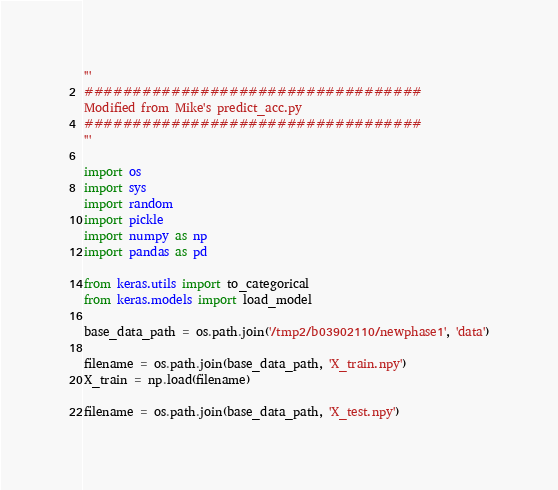Convert code to text. <code><loc_0><loc_0><loc_500><loc_500><_Python_>'''
###################################
Modified from Mike's predict_acc.py
###################################
'''

import os
import sys
import random
import pickle
import numpy as np
import pandas as pd

from keras.utils import to_categorical
from keras.models import load_model

base_data_path = os.path.join('/tmp2/b03902110/newphase1', 'data')

filename = os.path.join(base_data_path, 'X_train.npy')
X_train = np.load(filename)

filename = os.path.join(base_data_path, 'X_test.npy')</code> 